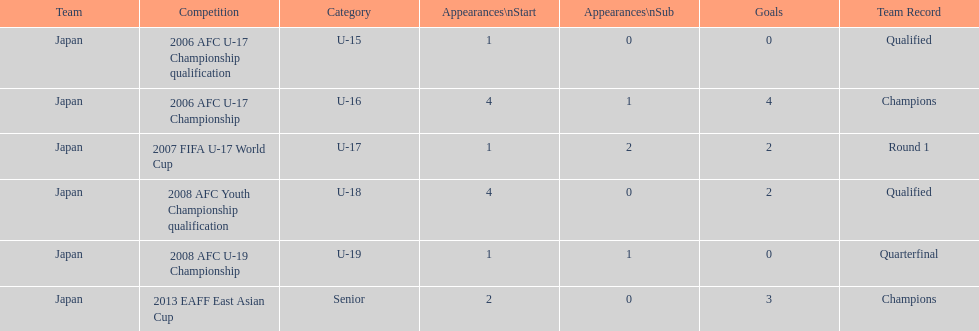How many major events featured yoichiro kakitani scoring at least two goals? 2. 